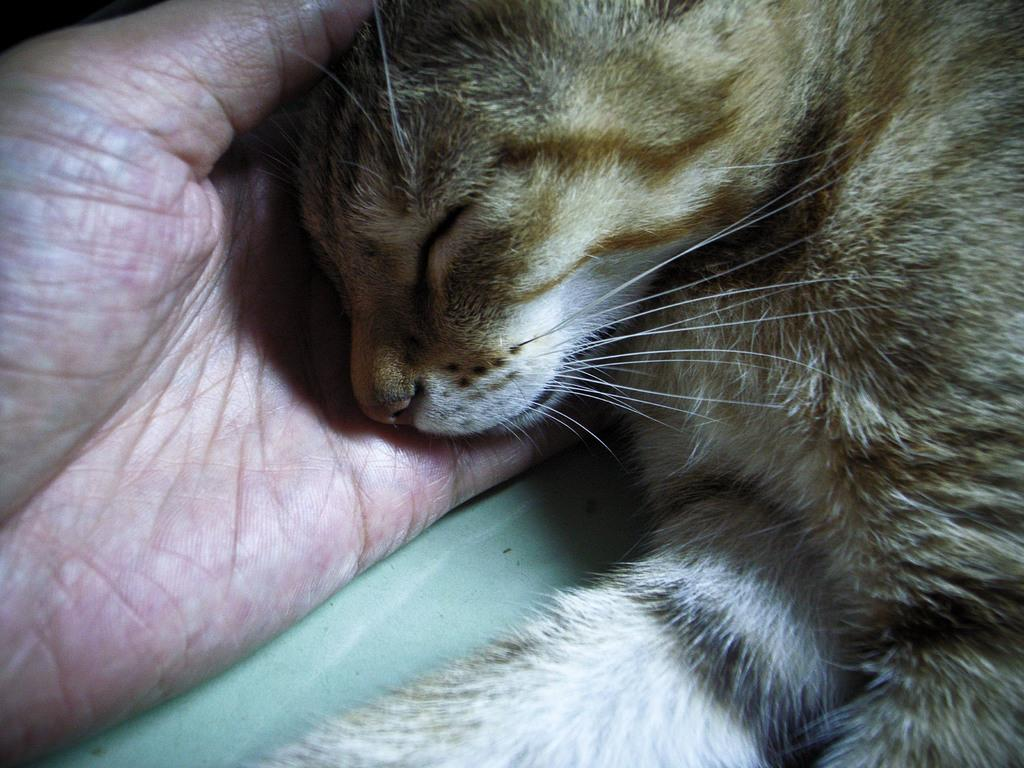What animal is present in the image? There is a lion cub in the image. What is the lion cub doing in the image? The lion cub is sleeping. Who is holding the lion cub in the image? The lion cub is in the hand of a person. What rule is the lion cub enforcing in the image? The lion cub is not enforcing any rule in the image; it is sleeping in the hand of a person. 